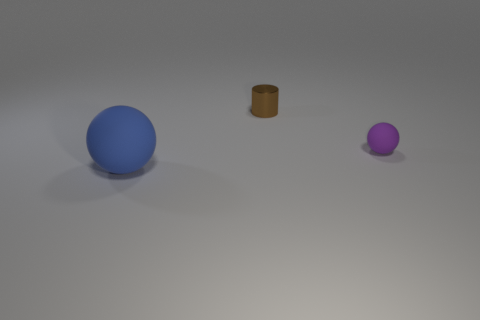Subtract all purple spheres. How many spheres are left? 1 Add 3 cylinders. How many objects exist? 6 Subtract 1 balls. How many balls are left? 1 Add 2 small yellow shiny cubes. How many small yellow shiny cubes exist? 2 Subtract 0 yellow cylinders. How many objects are left? 3 Subtract all cylinders. How many objects are left? 2 Subtract all brown spheres. Subtract all brown cylinders. How many spheres are left? 2 Subtract all cyan cylinders. How many cyan balls are left? 0 Subtract all yellow metal blocks. Subtract all big objects. How many objects are left? 2 Add 3 tiny balls. How many tiny balls are left? 4 